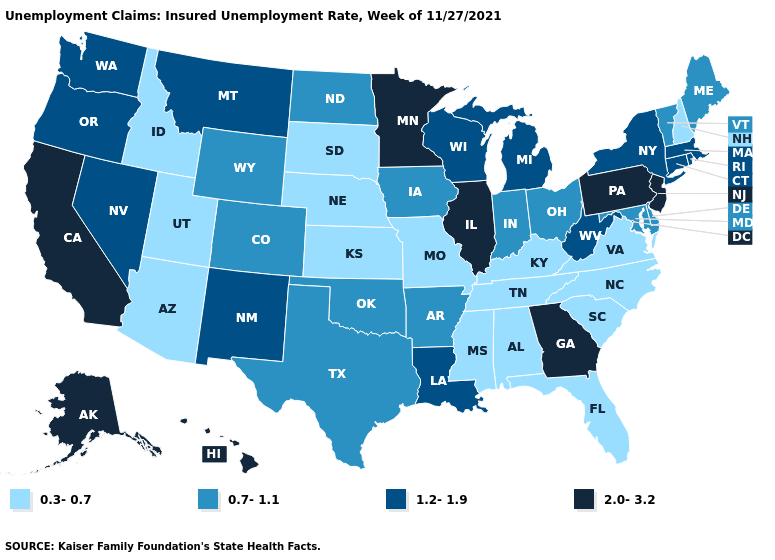Name the states that have a value in the range 0.3-0.7?
Answer briefly. Alabama, Arizona, Florida, Idaho, Kansas, Kentucky, Mississippi, Missouri, Nebraska, New Hampshire, North Carolina, South Carolina, South Dakota, Tennessee, Utah, Virginia. Name the states that have a value in the range 2.0-3.2?
Answer briefly. Alaska, California, Georgia, Hawaii, Illinois, Minnesota, New Jersey, Pennsylvania. What is the highest value in the West ?
Write a very short answer. 2.0-3.2. What is the lowest value in the USA?
Be succinct. 0.3-0.7. Does Connecticut have a lower value than Michigan?
Concise answer only. No. How many symbols are there in the legend?
Short answer required. 4. Is the legend a continuous bar?
Answer briefly. No. Does Nevada have a higher value than New Hampshire?
Give a very brief answer. Yes. What is the lowest value in states that border Utah?
Concise answer only. 0.3-0.7. Which states hav the highest value in the MidWest?
Write a very short answer. Illinois, Minnesota. Name the states that have a value in the range 2.0-3.2?
Short answer required. Alaska, California, Georgia, Hawaii, Illinois, Minnesota, New Jersey, Pennsylvania. What is the value of Texas?
Be succinct. 0.7-1.1. Name the states that have a value in the range 1.2-1.9?
Short answer required. Connecticut, Louisiana, Massachusetts, Michigan, Montana, Nevada, New Mexico, New York, Oregon, Rhode Island, Washington, West Virginia, Wisconsin. Name the states that have a value in the range 0.7-1.1?
Answer briefly. Arkansas, Colorado, Delaware, Indiana, Iowa, Maine, Maryland, North Dakota, Ohio, Oklahoma, Texas, Vermont, Wyoming. 